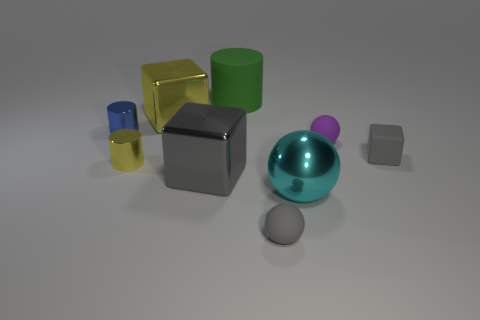Subtract all gray blocks. How many blocks are left? 1 Add 1 large yellow metal things. How many objects exist? 10 Subtract all blue cylinders. How many cylinders are left? 2 Subtract all cylinders. How many objects are left? 6 Subtract 1 spheres. How many spheres are left? 2 Subtract all brown balls. Subtract all blue cylinders. How many balls are left? 3 Subtract all gray balls. How many yellow cubes are left? 1 Subtract all shiny objects. Subtract all tiny green rubber cylinders. How many objects are left? 4 Add 1 small metal objects. How many small metal objects are left? 3 Add 7 tiny matte objects. How many tiny matte objects exist? 10 